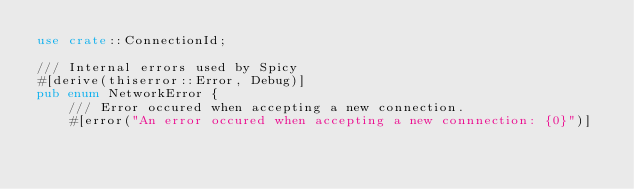<code> <loc_0><loc_0><loc_500><loc_500><_Rust_>use crate::ConnectionId;

/// Internal errors used by Spicy
#[derive(thiserror::Error, Debug)]
pub enum NetworkError {
    /// Error occured when accepting a new connection.
    #[error("An error occured when accepting a new connnection: {0}")]</code> 